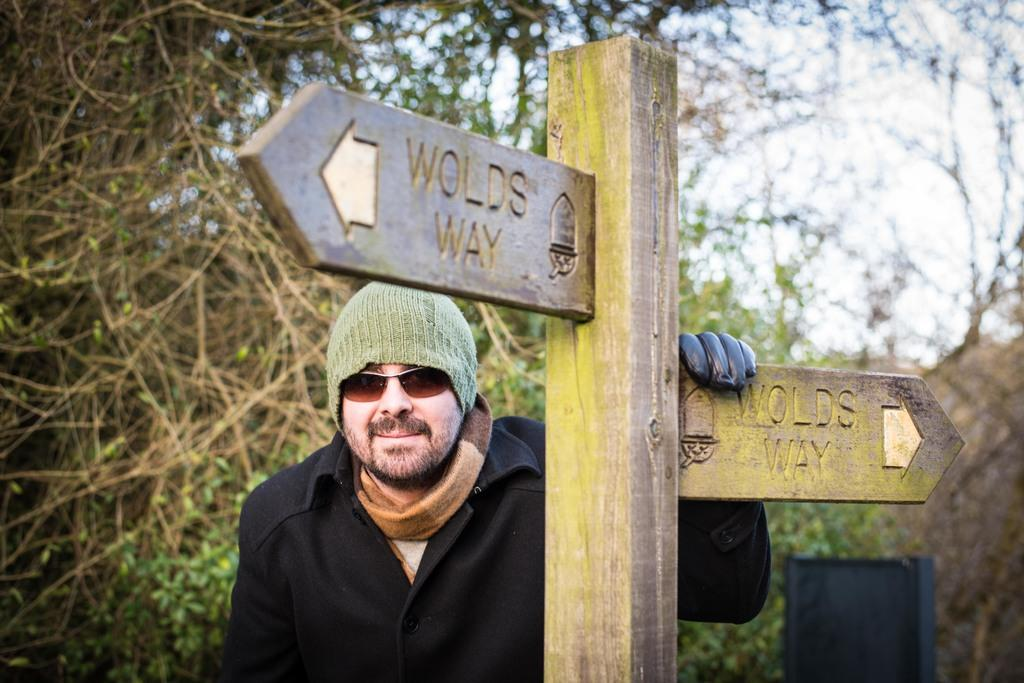Who or what is present in the image? There is a person in the image. What is the person wearing on their head? The person is wearing a cap. What type of natural environment can be seen in the image? There are trees in the image. What material is the wooden object made of? The wooden object is made of wood. What language is the person speaking in the image? There is no indication of the person speaking in the image, so it cannot be determined what language they might be using. 